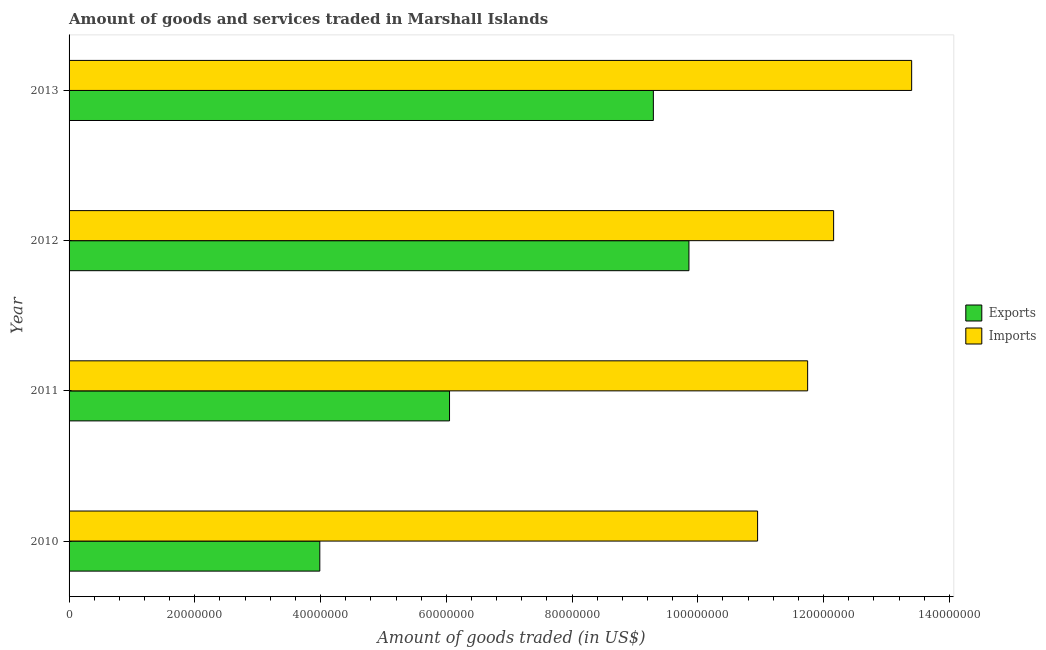How many groups of bars are there?
Offer a very short reply. 4. Are the number of bars per tick equal to the number of legend labels?
Provide a succinct answer. Yes. Are the number of bars on each tick of the Y-axis equal?
Give a very brief answer. Yes. How many bars are there on the 1st tick from the top?
Give a very brief answer. 2. How many bars are there on the 4th tick from the bottom?
Your answer should be very brief. 2. What is the label of the 1st group of bars from the top?
Keep it short and to the point. 2013. What is the amount of goods exported in 2012?
Ensure brevity in your answer.  9.86e+07. Across all years, what is the maximum amount of goods exported?
Offer a very short reply. 9.86e+07. Across all years, what is the minimum amount of goods imported?
Keep it short and to the point. 1.10e+08. In which year was the amount of goods exported maximum?
Your answer should be compact. 2012. In which year was the amount of goods imported minimum?
Offer a very short reply. 2010. What is the total amount of goods exported in the graph?
Offer a very short reply. 2.92e+08. What is the difference between the amount of goods exported in 2010 and that in 2012?
Offer a very short reply. -5.87e+07. What is the difference between the amount of goods exported in 2013 and the amount of goods imported in 2011?
Make the answer very short. -2.45e+07. What is the average amount of goods exported per year?
Your answer should be compact. 7.30e+07. In the year 2011, what is the difference between the amount of goods exported and amount of goods imported?
Provide a short and direct response. -5.70e+07. In how many years, is the amount of goods imported greater than 136000000 US$?
Offer a terse response. 0. What is the ratio of the amount of goods imported in 2011 to that in 2012?
Provide a succinct answer. 0.97. What is the difference between the highest and the second highest amount of goods exported?
Ensure brevity in your answer.  5.66e+06. What is the difference between the highest and the lowest amount of goods imported?
Give a very brief answer. 2.45e+07. What does the 1st bar from the top in 2011 represents?
Ensure brevity in your answer.  Imports. What does the 1st bar from the bottom in 2010 represents?
Your answer should be very brief. Exports. How many bars are there?
Provide a short and direct response. 8. Are all the bars in the graph horizontal?
Give a very brief answer. Yes. Are the values on the major ticks of X-axis written in scientific E-notation?
Keep it short and to the point. No. Does the graph contain grids?
Provide a short and direct response. No. Where does the legend appear in the graph?
Your response must be concise. Center right. How many legend labels are there?
Provide a succinct answer. 2. What is the title of the graph?
Offer a terse response. Amount of goods and services traded in Marshall Islands. What is the label or title of the X-axis?
Give a very brief answer. Amount of goods traded (in US$). What is the Amount of goods traded (in US$) in Exports in 2010?
Offer a very short reply. 3.99e+07. What is the Amount of goods traded (in US$) of Imports in 2010?
Make the answer very short. 1.10e+08. What is the Amount of goods traded (in US$) in Exports in 2011?
Offer a terse response. 6.05e+07. What is the Amount of goods traded (in US$) in Imports in 2011?
Your answer should be very brief. 1.17e+08. What is the Amount of goods traded (in US$) in Exports in 2012?
Keep it short and to the point. 9.86e+07. What is the Amount of goods traded (in US$) of Imports in 2012?
Provide a short and direct response. 1.22e+08. What is the Amount of goods traded (in US$) of Exports in 2013?
Your answer should be very brief. 9.29e+07. What is the Amount of goods traded (in US$) in Imports in 2013?
Your answer should be very brief. 1.34e+08. Across all years, what is the maximum Amount of goods traded (in US$) in Exports?
Your answer should be compact. 9.86e+07. Across all years, what is the maximum Amount of goods traded (in US$) in Imports?
Offer a very short reply. 1.34e+08. Across all years, what is the minimum Amount of goods traded (in US$) in Exports?
Provide a short and direct response. 3.99e+07. Across all years, what is the minimum Amount of goods traded (in US$) in Imports?
Provide a succinct answer. 1.10e+08. What is the total Amount of goods traded (in US$) of Exports in the graph?
Your answer should be compact. 2.92e+08. What is the total Amount of goods traded (in US$) of Imports in the graph?
Provide a succinct answer. 4.83e+08. What is the difference between the Amount of goods traded (in US$) of Exports in 2010 and that in 2011?
Offer a very short reply. -2.06e+07. What is the difference between the Amount of goods traded (in US$) of Imports in 2010 and that in 2011?
Offer a very short reply. -7.96e+06. What is the difference between the Amount of goods traded (in US$) of Exports in 2010 and that in 2012?
Keep it short and to the point. -5.87e+07. What is the difference between the Amount of goods traded (in US$) of Imports in 2010 and that in 2012?
Keep it short and to the point. -1.21e+07. What is the difference between the Amount of goods traded (in US$) of Exports in 2010 and that in 2013?
Provide a short and direct response. -5.31e+07. What is the difference between the Amount of goods traded (in US$) of Imports in 2010 and that in 2013?
Provide a succinct answer. -2.45e+07. What is the difference between the Amount of goods traded (in US$) in Exports in 2011 and that in 2012?
Provide a short and direct response. -3.81e+07. What is the difference between the Amount of goods traded (in US$) in Imports in 2011 and that in 2012?
Your answer should be very brief. -4.13e+06. What is the difference between the Amount of goods traded (in US$) of Exports in 2011 and that in 2013?
Keep it short and to the point. -3.24e+07. What is the difference between the Amount of goods traded (in US$) of Imports in 2011 and that in 2013?
Make the answer very short. -1.65e+07. What is the difference between the Amount of goods traded (in US$) of Exports in 2012 and that in 2013?
Make the answer very short. 5.66e+06. What is the difference between the Amount of goods traded (in US$) in Imports in 2012 and that in 2013?
Give a very brief answer. -1.24e+07. What is the difference between the Amount of goods traded (in US$) of Exports in 2010 and the Amount of goods traded (in US$) of Imports in 2011?
Make the answer very short. -7.76e+07. What is the difference between the Amount of goods traded (in US$) of Exports in 2010 and the Amount of goods traded (in US$) of Imports in 2012?
Provide a succinct answer. -8.17e+07. What is the difference between the Amount of goods traded (in US$) of Exports in 2010 and the Amount of goods traded (in US$) of Imports in 2013?
Your response must be concise. -9.41e+07. What is the difference between the Amount of goods traded (in US$) in Exports in 2011 and the Amount of goods traded (in US$) in Imports in 2012?
Your response must be concise. -6.11e+07. What is the difference between the Amount of goods traded (in US$) of Exports in 2011 and the Amount of goods traded (in US$) of Imports in 2013?
Provide a succinct answer. -7.35e+07. What is the difference between the Amount of goods traded (in US$) of Exports in 2012 and the Amount of goods traded (in US$) of Imports in 2013?
Make the answer very short. -3.54e+07. What is the average Amount of goods traded (in US$) in Exports per year?
Give a very brief answer. 7.30e+07. What is the average Amount of goods traded (in US$) of Imports per year?
Provide a succinct answer. 1.21e+08. In the year 2010, what is the difference between the Amount of goods traded (in US$) of Exports and Amount of goods traded (in US$) of Imports?
Make the answer very short. -6.96e+07. In the year 2011, what is the difference between the Amount of goods traded (in US$) in Exports and Amount of goods traded (in US$) in Imports?
Offer a terse response. -5.70e+07. In the year 2012, what is the difference between the Amount of goods traded (in US$) of Exports and Amount of goods traded (in US$) of Imports?
Offer a terse response. -2.30e+07. In the year 2013, what is the difference between the Amount of goods traded (in US$) of Exports and Amount of goods traded (in US$) of Imports?
Offer a very short reply. -4.11e+07. What is the ratio of the Amount of goods traded (in US$) of Exports in 2010 to that in 2011?
Keep it short and to the point. 0.66. What is the ratio of the Amount of goods traded (in US$) of Imports in 2010 to that in 2011?
Give a very brief answer. 0.93. What is the ratio of the Amount of goods traded (in US$) of Exports in 2010 to that in 2012?
Give a very brief answer. 0.4. What is the ratio of the Amount of goods traded (in US$) of Imports in 2010 to that in 2012?
Keep it short and to the point. 0.9. What is the ratio of the Amount of goods traded (in US$) of Exports in 2010 to that in 2013?
Give a very brief answer. 0.43. What is the ratio of the Amount of goods traded (in US$) of Imports in 2010 to that in 2013?
Your response must be concise. 0.82. What is the ratio of the Amount of goods traded (in US$) of Exports in 2011 to that in 2012?
Offer a very short reply. 0.61. What is the ratio of the Amount of goods traded (in US$) of Exports in 2011 to that in 2013?
Your answer should be very brief. 0.65. What is the ratio of the Amount of goods traded (in US$) in Imports in 2011 to that in 2013?
Keep it short and to the point. 0.88. What is the ratio of the Amount of goods traded (in US$) of Exports in 2012 to that in 2013?
Your answer should be compact. 1.06. What is the ratio of the Amount of goods traded (in US$) in Imports in 2012 to that in 2013?
Keep it short and to the point. 0.91. What is the difference between the highest and the second highest Amount of goods traded (in US$) of Exports?
Provide a succinct answer. 5.66e+06. What is the difference between the highest and the second highest Amount of goods traded (in US$) of Imports?
Provide a succinct answer. 1.24e+07. What is the difference between the highest and the lowest Amount of goods traded (in US$) in Exports?
Provide a short and direct response. 5.87e+07. What is the difference between the highest and the lowest Amount of goods traded (in US$) in Imports?
Offer a terse response. 2.45e+07. 